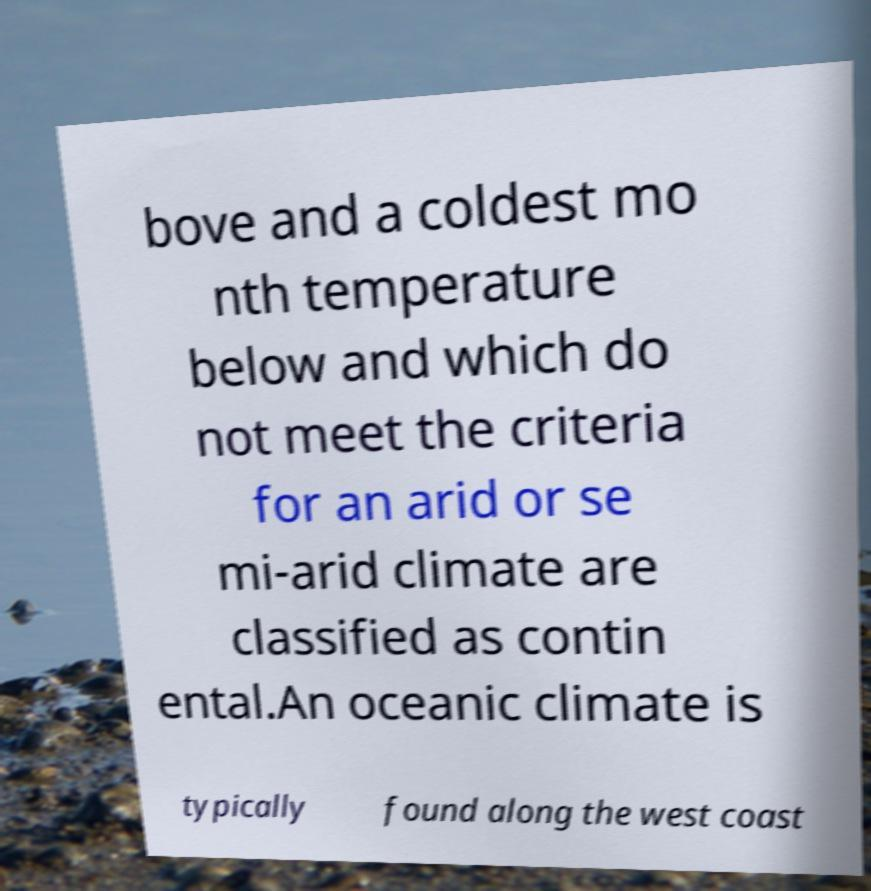Can you read and provide the text displayed in the image?This photo seems to have some interesting text. Can you extract and type it out for me? bove and a coldest mo nth temperature below and which do not meet the criteria for an arid or se mi-arid climate are classified as contin ental.An oceanic climate is typically found along the west coast 